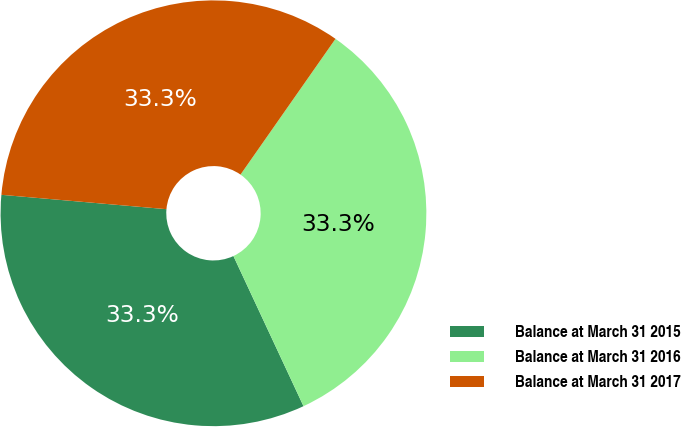<chart> <loc_0><loc_0><loc_500><loc_500><pie_chart><fcel>Balance at March 31 2015<fcel>Balance at March 31 2016<fcel>Balance at March 31 2017<nl><fcel>33.33%<fcel>33.33%<fcel>33.33%<nl></chart> 